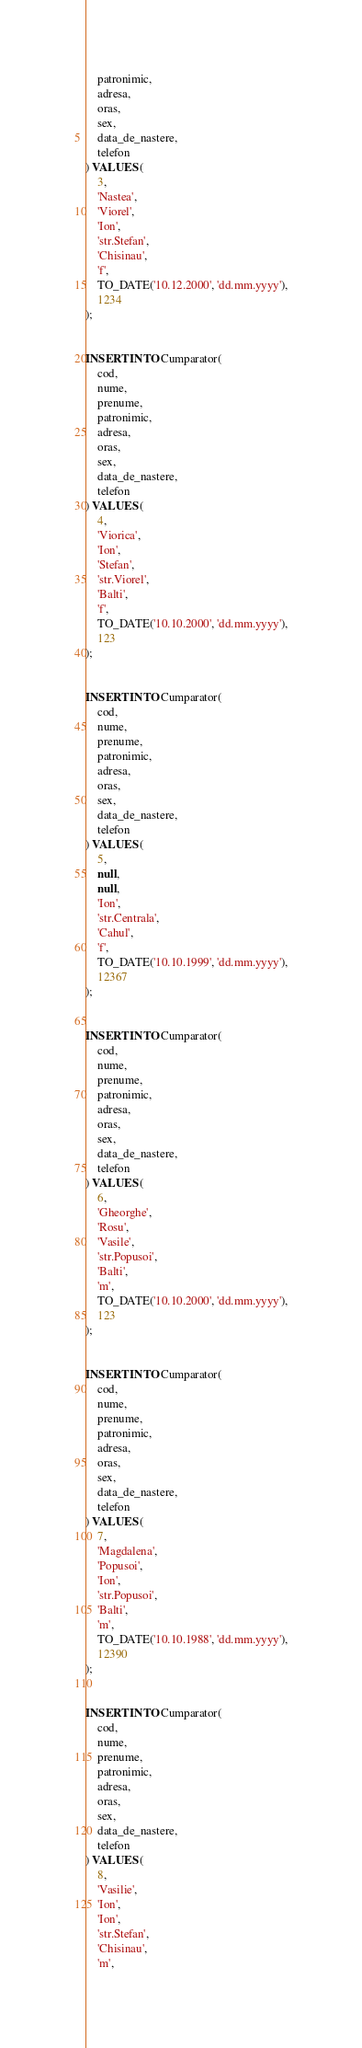<code> <loc_0><loc_0><loc_500><loc_500><_SQL_>    patronimic,
    adresa,
    oras,
    sex,
    data_de_nastere,
    telefon
) VALUES (
    3,
    'Nastea',
    'Viorel',
    'Ion',
    'str.Stefan',
    'Chisinau',
    'f',
    TO_DATE('10.12.2000', 'dd.mm.yyyy'),
    1234
);


INSERT INTO Cumparator(
    cod,
    nume,
    prenume,
    patronimic,
    adresa,
    oras,
    sex,
    data_de_nastere,
    telefon
) VALUES (
    4,
    'Viorica',
    'Ion',
    'Stefan',
    'str.Viorel',
    'Balti',
    'f',
    TO_DATE('10.10.2000', 'dd.mm.yyyy'),
    123
);


INSERT INTO Cumparator(
    cod,
    nume,
    prenume,
    patronimic,
    adresa,
    oras,
    sex,
    data_de_nastere,
    telefon
) VALUES (
    5,
    null,
    null,
    'Ion',
    'str.Centrala',
    'Cahul',
    'f',
    TO_DATE('10.10.1999', 'dd.mm.yyyy'),
    12367
);


INSERT INTO Cumparator(
    cod,
    nume,
    prenume,
    patronimic,
    adresa,
    oras,
    sex,
    data_de_nastere,
    telefon
) VALUES (
    6,
    'Gheorghe',
    'Rosu',
    'Vasile',
    'str.Popusoi',
    'Balti',
    'm',
    TO_DATE('10.10.2000', 'dd.mm.yyyy'),
    123
);


INSERT INTO Cumparator(
    cod,
    nume,
    prenume,
    patronimic,
    adresa,
    oras,
    sex,
    data_de_nastere,
    telefon
) VALUES (
    7,
    'Magdalena',
    'Popusoi',
    'Ion',
    'str.Popusoi',
    'Balti',
    'm',
    TO_DATE('10.10.1988', 'dd.mm.yyyy'),
    12390
);


INSERT INTO Cumparator(
    cod,
    nume,
    prenume,
    patronimic,
    adresa,
    oras,
    sex,
    data_de_nastere,
    telefon
) VALUES (
    8,
    'Vasilie',
    'Ion',
    'Ion',
    'str.Stefan',
    'Chisinau',
    'm',</code> 